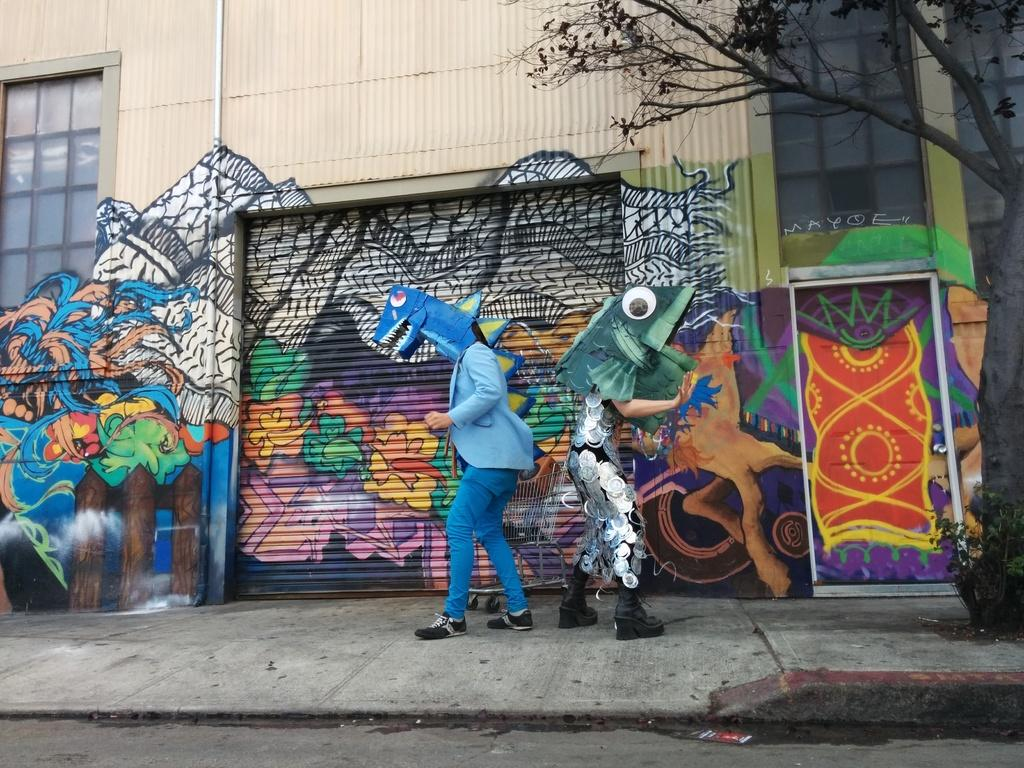What are the people in the center of the image wearing? The persons in the center of the image are wearing masks. What can be seen on the wall in the background? There is a painting on the wall in the background. What is located on the right side of the image? There is a tree on the right side of the image. What feature allows light to enter the room in the image? There are windows in the image. What type of tail can be seen on the persons wearing masks in the image? There are no tails visible on the persons wearing masks in the image. What color is the sweater worn by the tree in the image? There is no sweater present on the tree in the image, as trees do not wear clothing. 